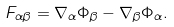Convert formula to latex. <formula><loc_0><loc_0><loc_500><loc_500>F _ { \alpha \beta } = \nabla _ { \alpha } \Phi _ { \beta } - \nabla _ { \beta } \Phi _ { \alpha } .</formula> 